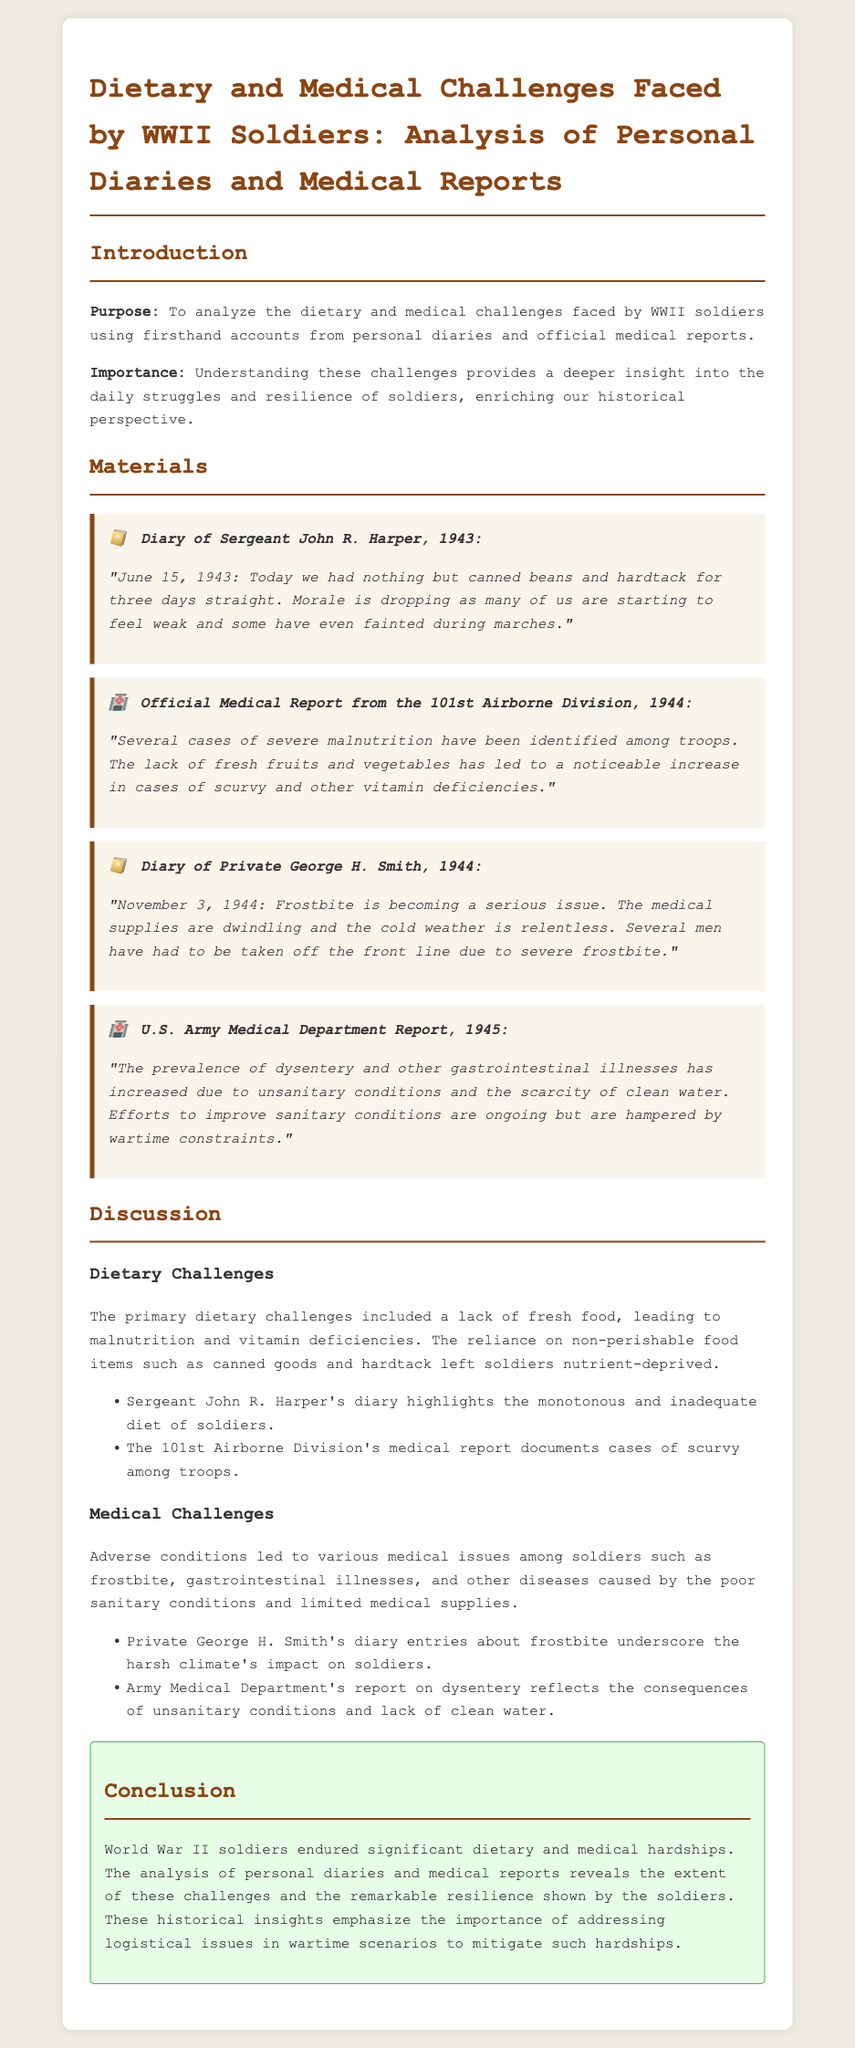what is the purpose of the report? The purpose is to analyze the dietary and medical challenges faced by WWII soldiers using firsthand accounts.
Answer: To analyze the dietary and medical challenges faced by WWII soldiers who wrote the diary entry dated June 15, 1943? The diary entry dated June 15, 1943 was written by Sergeant John R. Harper.
Answer: Sergeant John R. Harper what medical issue was reported among troops in the 101st Airborne Division? The medical report highlights cases of severe malnutrition among troops.
Answer: Severe malnutrition which vegetable deficiency led to an increase in cases of scurvy? The lack of fresh fruits and vegetables led to an increase in scurvy.
Answer: Fresh fruits and vegetables how many diary entries focus on frostbite issues? There are two diary entries focusing on frostbite issues.
Answer: Two what year did Private George H. Smith make his diary entry? Private George H. Smith made his diary entry in 1944.
Answer: 1944 what document type is analyzed in this report alongside personal diaries? The report analyzes official medical reports alongside personal diaries.
Answer: Official medical reports what overall tone does the conclusion of the report convey about soldiers' experiences? The conclusion conveys a tone of resilience regarding the soldiers' experiences.
Answer: Resilience 